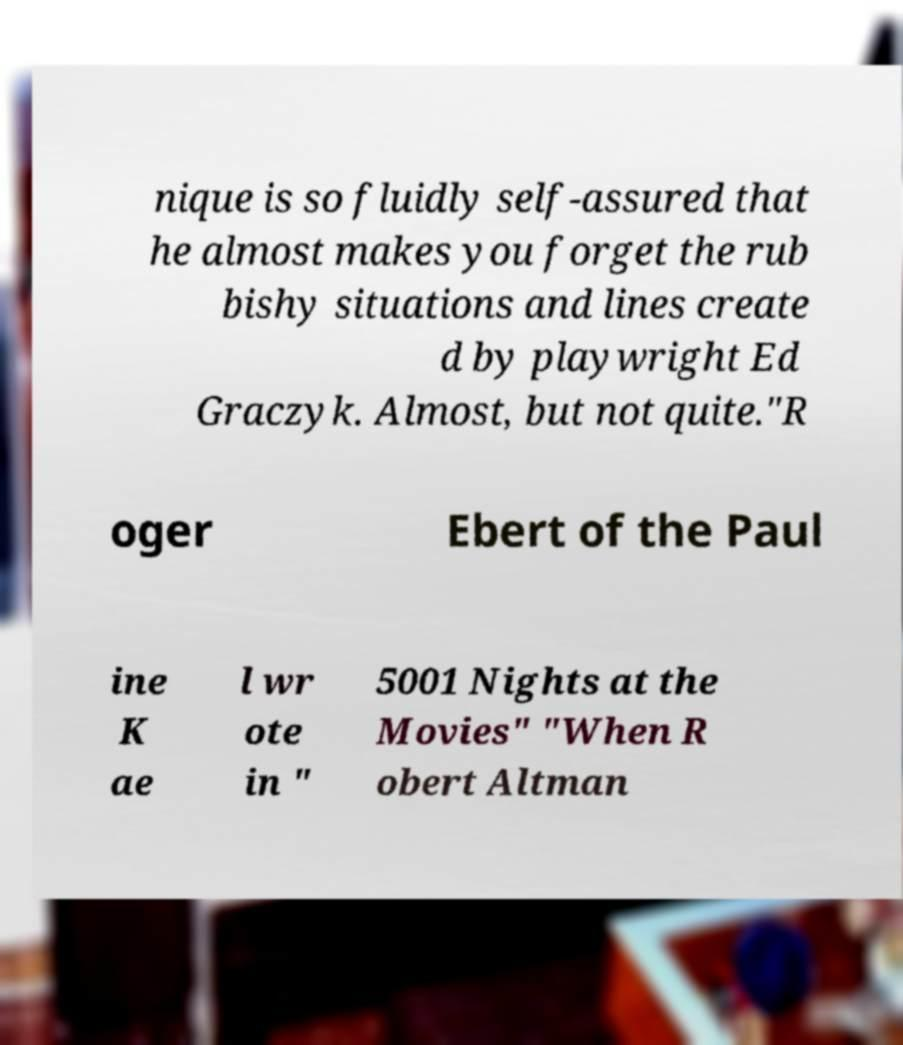Could you extract and type out the text from this image? nique is so fluidly self-assured that he almost makes you forget the rub bishy situations and lines create d by playwright Ed Graczyk. Almost, but not quite."R oger Ebert of the Paul ine K ae l wr ote in " 5001 Nights at the Movies" "When R obert Altman 